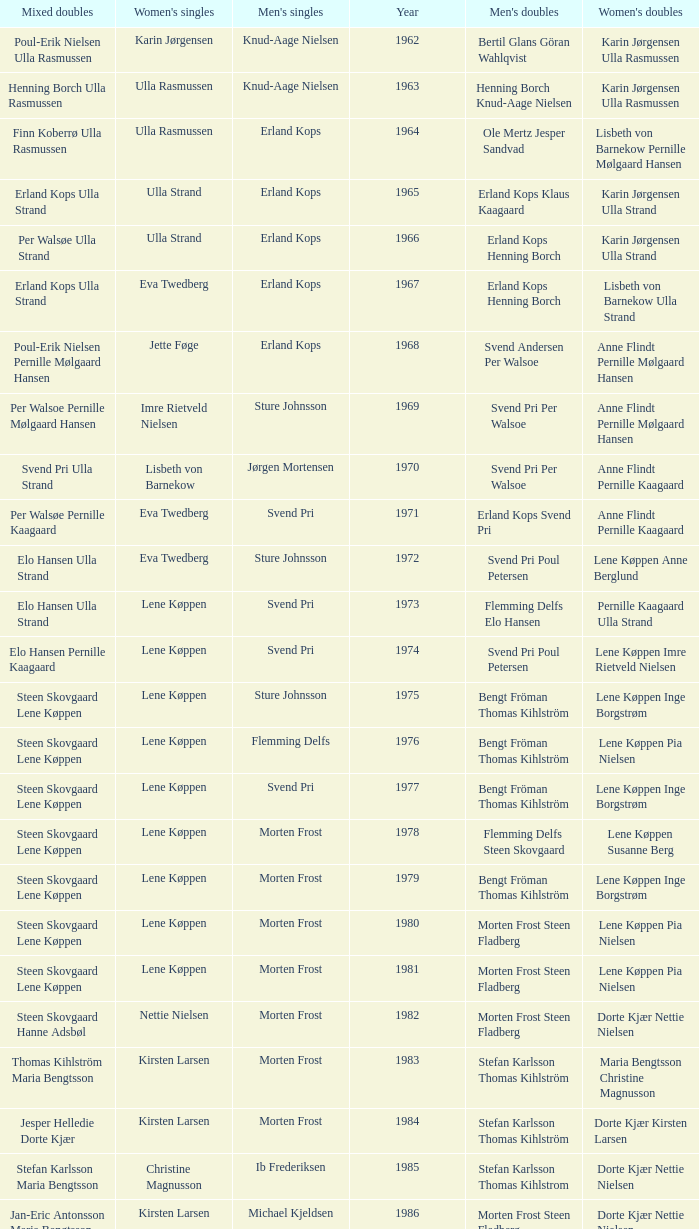Who won the men's doubles the year Pernille Nedergaard won the women's singles? Thomas Stuer-Lauridsen Max Gandrup. Parse the full table. {'header': ['Mixed doubles', "Women's singles", "Men's singles", 'Year', "Men's doubles", "Women's doubles"], 'rows': [['Poul-Erik Nielsen Ulla Rasmussen', 'Karin Jørgensen', 'Knud-Aage Nielsen', '1962', 'Bertil Glans Göran Wahlqvist', 'Karin Jørgensen Ulla Rasmussen'], ['Henning Borch Ulla Rasmussen', 'Ulla Rasmussen', 'Knud-Aage Nielsen', '1963', 'Henning Borch Knud-Aage Nielsen', 'Karin Jørgensen Ulla Rasmussen'], ['Finn Koberrø Ulla Rasmussen', 'Ulla Rasmussen', 'Erland Kops', '1964', 'Ole Mertz Jesper Sandvad', 'Lisbeth von Barnekow Pernille Mølgaard Hansen'], ['Erland Kops Ulla Strand', 'Ulla Strand', 'Erland Kops', '1965', 'Erland Kops Klaus Kaagaard', 'Karin Jørgensen Ulla Strand'], ['Per Walsøe Ulla Strand', 'Ulla Strand', 'Erland Kops', '1966', 'Erland Kops Henning Borch', 'Karin Jørgensen Ulla Strand'], ['Erland Kops Ulla Strand', 'Eva Twedberg', 'Erland Kops', '1967', 'Erland Kops Henning Borch', 'Lisbeth von Barnekow Ulla Strand'], ['Poul-Erik Nielsen Pernille Mølgaard Hansen', 'Jette Føge', 'Erland Kops', '1968', 'Svend Andersen Per Walsoe', 'Anne Flindt Pernille Mølgaard Hansen'], ['Per Walsoe Pernille Mølgaard Hansen', 'Imre Rietveld Nielsen', 'Sture Johnsson', '1969', 'Svend Pri Per Walsoe', 'Anne Flindt Pernille Mølgaard Hansen'], ['Svend Pri Ulla Strand', 'Lisbeth von Barnekow', 'Jørgen Mortensen', '1970', 'Svend Pri Per Walsoe', 'Anne Flindt Pernille Kaagaard'], ['Per Walsøe Pernille Kaagaard', 'Eva Twedberg', 'Svend Pri', '1971', 'Erland Kops Svend Pri', 'Anne Flindt Pernille Kaagaard'], ['Elo Hansen Ulla Strand', 'Eva Twedberg', 'Sture Johnsson', '1972', 'Svend Pri Poul Petersen', 'Lene Køppen Anne Berglund'], ['Elo Hansen Ulla Strand', 'Lene Køppen', 'Svend Pri', '1973', 'Flemming Delfs Elo Hansen', 'Pernille Kaagaard Ulla Strand'], ['Elo Hansen Pernille Kaagaard', 'Lene Køppen', 'Svend Pri', '1974', 'Svend Pri Poul Petersen', 'Lene Køppen Imre Rietveld Nielsen'], ['Steen Skovgaard Lene Køppen', 'Lene Køppen', 'Sture Johnsson', '1975', 'Bengt Fröman Thomas Kihlström', 'Lene Køppen Inge Borgstrøm'], ['Steen Skovgaard Lene Køppen', 'Lene Køppen', 'Flemming Delfs', '1976', 'Bengt Fröman Thomas Kihlström', 'Lene Køppen Pia Nielsen'], ['Steen Skovgaard Lene Køppen', 'Lene Køppen', 'Svend Pri', '1977', 'Bengt Fröman Thomas Kihlström', 'Lene Køppen Inge Borgstrøm'], ['Steen Skovgaard Lene Køppen', 'Lene Køppen', 'Morten Frost', '1978', 'Flemming Delfs Steen Skovgaard', 'Lene Køppen Susanne Berg'], ['Steen Skovgaard Lene Køppen', 'Lene Køppen', 'Morten Frost', '1979', 'Bengt Fröman Thomas Kihlström', 'Lene Køppen Inge Borgstrøm'], ['Steen Skovgaard Lene Køppen', 'Lene Køppen', 'Morten Frost', '1980', 'Morten Frost Steen Fladberg', 'Lene Køppen Pia Nielsen'], ['Steen Skovgaard Lene Køppen', 'Lene Køppen', 'Morten Frost', '1981', 'Morten Frost Steen Fladberg', 'Lene Køppen Pia Nielsen'], ['Steen Skovgaard Hanne Adsbøl', 'Nettie Nielsen', 'Morten Frost', '1982', 'Morten Frost Steen Fladberg', 'Dorte Kjær Nettie Nielsen'], ['Thomas Kihlström Maria Bengtsson', 'Kirsten Larsen', 'Morten Frost', '1983', 'Stefan Karlsson Thomas Kihlström', 'Maria Bengtsson Christine Magnusson'], ['Jesper Helledie Dorte Kjær', 'Kirsten Larsen', 'Morten Frost', '1984', 'Stefan Karlsson Thomas Kihlström', 'Dorte Kjær Kirsten Larsen'], ['Stefan Karlsson Maria Bengtsson', 'Christine Magnusson', 'Ib Frederiksen', '1985', 'Stefan Karlsson Thomas Kihlstrom', 'Dorte Kjær Nettie Nielsen'], ['Jan-Eric Antonsson Maria Bengtsson', 'Kirsten Larsen', 'Michael Kjeldsen', '1986', 'Morten Frost Steen Fladberg', 'Dorte Kjær Nettie Nielsen'], ['Jesper Knudsen Nettie Nielsen', 'Christina Bostofte', 'Michael Kjeldsen', '1987', 'Steen Fladberg Jan Paulsen', 'Dorte Kjær Nettie Nielsen'], ['Jesper Knudsen Nettie Nielsen', 'Kirsten Larsen', 'Morten Frost', '1988', 'Jens Peter Nierhoff Michael Kjeldsen', 'Dorte Kjær Nettie Nielsen'], ['Thomas Lund Pernille Dupont', 'Pernille Nedergaard', 'Poul Erik Hoyer Larsen', '1990', 'Thomas Stuer-Lauridsen Max Gandrup', 'Dorte Kjær Lotte Olsen'], ['Par Gunnar Jönsson Maria Bengtsson', 'Christine Magnusson', 'Thomas Stuer-Lauridsen', '1992', 'Jon Holst-Christensen Jan Paulsen', 'Christine Magnusson Lim Xiao Qing'], ['Michael Søgaard Rikke Olsen', 'Lim Xiao Qing', 'Thomas Stuer-Lauridsen', '1995', 'Michael Søgaard Henrik Svarrer', 'Rikke Olsen Helene Kirkegaard'], ['Jens Eriksen Marlene Thomsen', 'Camilla Martin', 'Peter Rasmussen', '1997', 'Jesper Larsen Jens Eriksen', 'Rikke Olsen Helene Kirkegaard'], ['Fredrik Bergström Jenny Karlsson', 'Mette Sørensen', 'Thomas Johansson', '1999', 'Thomas Stavngaard Lars Paaske', 'Ann-Lou Jørgensen Mette Schjoldager']]} 